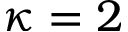<formula> <loc_0><loc_0><loc_500><loc_500>\kappa = 2</formula> 